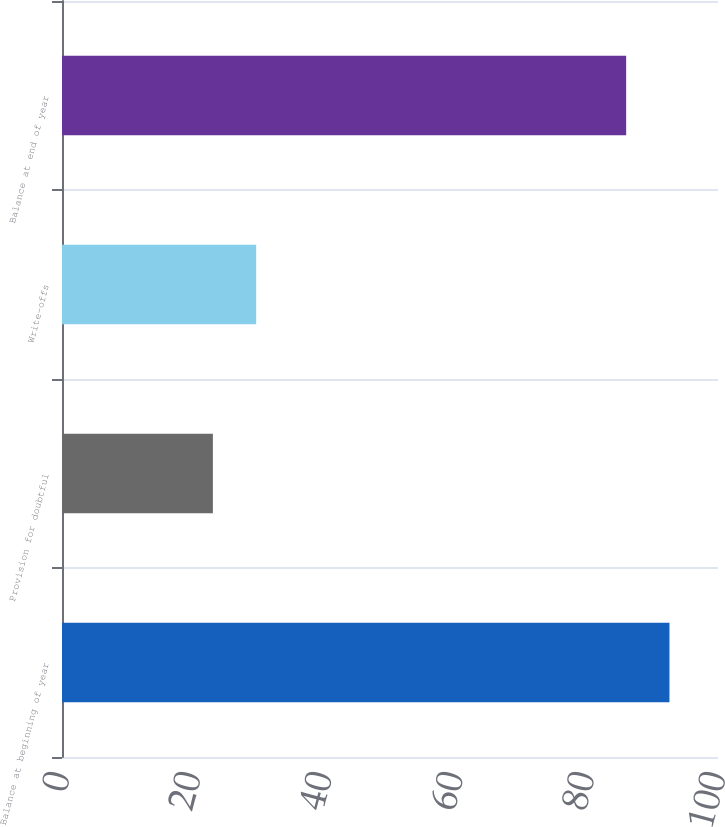Convert chart to OTSL. <chart><loc_0><loc_0><loc_500><loc_500><bar_chart><fcel>Balance at beginning of year<fcel>Provision for doubtful<fcel>Write-offs<fcel>Balance at end of year<nl><fcel>92.6<fcel>23<fcel>29.6<fcel>86<nl></chart> 